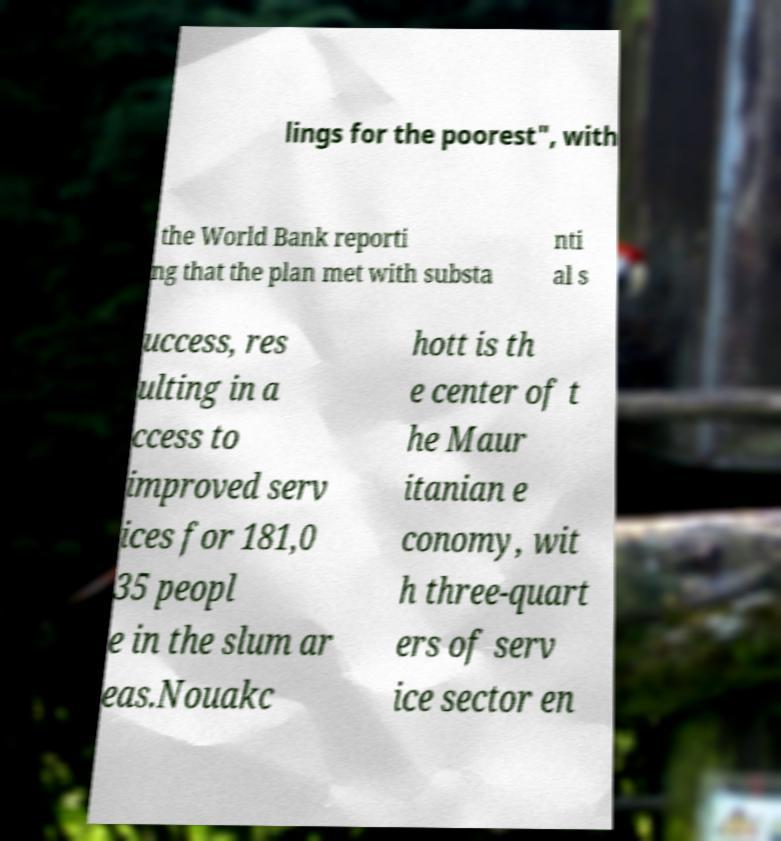I need the written content from this picture converted into text. Can you do that? lings for the poorest", with the World Bank reporti ng that the plan met with substa nti al s uccess, res ulting in a ccess to improved serv ices for 181,0 35 peopl e in the slum ar eas.Nouakc hott is th e center of t he Maur itanian e conomy, wit h three-quart ers of serv ice sector en 